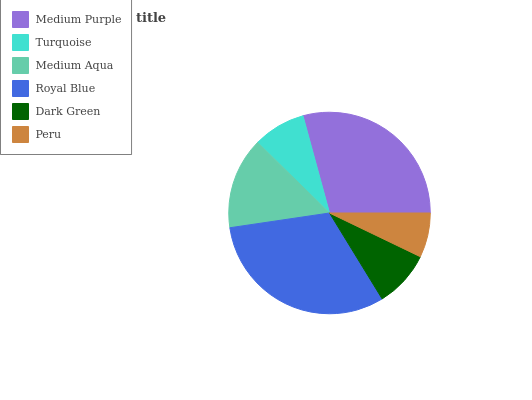Is Peru the minimum?
Answer yes or no. Yes. Is Royal Blue the maximum?
Answer yes or no. Yes. Is Turquoise the minimum?
Answer yes or no. No. Is Turquoise the maximum?
Answer yes or no. No. Is Medium Purple greater than Turquoise?
Answer yes or no. Yes. Is Turquoise less than Medium Purple?
Answer yes or no. Yes. Is Turquoise greater than Medium Purple?
Answer yes or no. No. Is Medium Purple less than Turquoise?
Answer yes or no. No. Is Medium Aqua the high median?
Answer yes or no. Yes. Is Dark Green the low median?
Answer yes or no. Yes. Is Turquoise the high median?
Answer yes or no. No. Is Medium Aqua the low median?
Answer yes or no. No. 